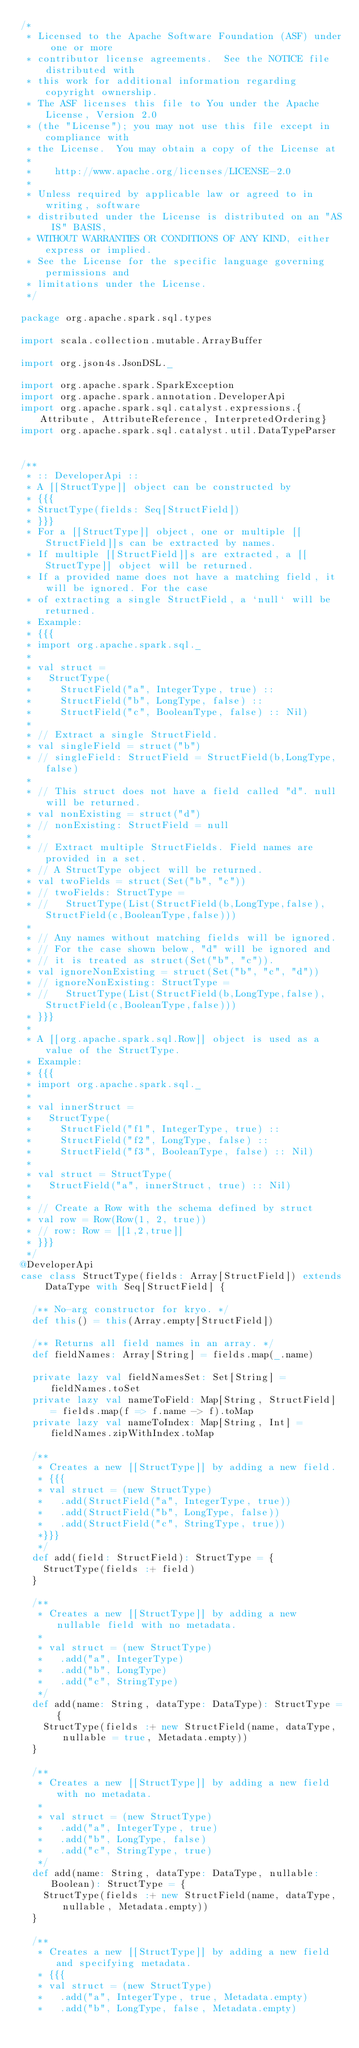<code> <loc_0><loc_0><loc_500><loc_500><_Scala_>/*
 * Licensed to the Apache Software Foundation (ASF) under one or more
 * contributor license agreements.  See the NOTICE file distributed with
 * this work for additional information regarding copyright ownership.
 * The ASF licenses this file to You under the Apache License, Version 2.0
 * (the "License"); you may not use this file except in compliance with
 * the License.  You may obtain a copy of the License at
 *
 *    http://www.apache.org/licenses/LICENSE-2.0
 *
 * Unless required by applicable law or agreed to in writing, software
 * distributed under the License is distributed on an "AS IS" BASIS,
 * WITHOUT WARRANTIES OR CONDITIONS OF ANY KIND, either express or implied.
 * See the License for the specific language governing permissions and
 * limitations under the License.
 */

package org.apache.spark.sql.types

import scala.collection.mutable.ArrayBuffer

import org.json4s.JsonDSL._

import org.apache.spark.SparkException
import org.apache.spark.annotation.DeveloperApi
import org.apache.spark.sql.catalyst.expressions.{Attribute, AttributeReference, InterpretedOrdering}
import org.apache.spark.sql.catalyst.util.DataTypeParser


/**
 * :: DeveloperApi ::
 * A [[StructType]] object can be constructed by
 * {{{
 * StructType(fields: Seq[StructField])
 * }}}
 * For a [[StructType]] object, one or multiple [[StructField]]s can be extracted by names.
 * If multiple [[StructField]]s are extracted, a [[StructType]] object will be returned.
 * If a provided name does not have a matching field, it will be ignored. For the case
 * of extracting a single StructField, a `null` will be returned.
 * Example:
 * {{{
 * import org.apache.spark.sql._
 *
 * val struct =
 *   StructType(
 *     StructField("a", IntegerType, true) ::
 *     StructField("b", LongType, false) ::
 *     StructField("c", BooleanType, false) :: Nil)
 *
 * // Extract a single StructField.
 * val singleField = struct("b")
 * // singleField: StructField = StructField(b,LongType,false)
 *
 * // This struct does not have a field called "d". null will be returned.
 * val nonExisting = struct("d")
 * // nonExisting: StructField = null
 *
 * // Extract multiple StructFields. Field names are provided in a set.
 * // A StructType object will be returned.
 * val twoFields = struct(Set("b", "c"))
 * // twoFields: StructType =
 * //   StructType(List(StructField(b,LongType,false), StructField(c,BooleanType,false)))
 *
 * // Any names without matching fields will be ignored.
 * // For the case shown below, "d" will be ignored and
 * // it is treated as struct(Set("b", "c")).
 * val ignoreNonExisting = struct(Set("b", "c", "d"))
 * // ignoreNonExisting: StructType =
 * //   StructType(List(StructField(b,LongType,false), StructField(c,BooleanType,false)))
 * }}}
 *
 * A [[org.apache.spark.sql.Row]] object is used as a value of the StructType.
 * Example:
 * {{{
 * import org.apache.spark.sql._
 *
 * val innerStruct =
 *   StructType(
 *     StructField("f1", IntegerType, true) ::
 *     StructField("f2", LongType, false) ::
 *     StructField("f3", BooleanType, false) :: Nil)
 *
 * val struct = StructType(
 *   StructField("a", innerStruct, true) :: Nil)
 *
 * // Create a Row with the schema defined by struct
 * val row = Row(Row(1, 2, true))
 * // row: Row = [[1,2,true]]
 * }}}
 */
@DeveloperApi
case class StructType(fields: Array[StructField]) extends DataType with Seq[StructField] {

  /** No-arg constructor for kryo. */
  def this() = this(Array.empty[StructField])

  /** Returns all field names in an array. */
  def fieldNames: Array[String] = fields.map(_.name)

  private lazy val fieldNamesSet: Set[String] = fieldNames.toSet
  private lazy val nameToField: Map[String, StructField] = fields.map(f => f.name -> f).toMap
  private lazy val nameToIndex: Map[String, Int] = fieldNames.zipWithIndex.toMap

  /**
   * Creates a new [[StructType]] by adding a new field.
   * {{{
   * val struct = (new StructType)
   *   .add(StructField("a", IntegerType, true))
   *   .add(StructField("b", LongType, false))
   *   .add(StructField("c", StringType, true))
   *}}}
   */
  def add(field: StructField): StructType = {
    StructType(fields :+ field)
  }

  /**
   * Creates a new [[StructType]] by adding a new nullable field with no metadata.
   *
   * val struct = (new StructType)
   *   .add("a", IntegerType)
   *   .add("b", LongType)
   *   .add("c", StringType)
   */
  def add(name: String, dataType: DataType): StructType = {
    StructType(fields :+ new StructField(name, dataType, nullable = true, Metadata.empty))
  }

  /**
   * Creates a new [[StructType]] by adding a new field with no metadata.
   *
   * val struct = (new StructType)
   *   .add("a", IntegerType, true)
   *   .add("b", LongType, false)
   *   .add("c", StringType, true)
   */
  def add(name: String, dataType: DataType, nullable: Boolean): StructType = {
    StructType(fields :+ new StructField(name, dataType, nullable, Metadata.empty))
  }

  /**
   * Creates a new [[StructType]] by adding a new field and specifying metadata.
   * {{{
   * val struct = (new StructType)
   *   .add("a", IntegerType, true, Metadata.empty)
   *   .add("b", LongType, false, Metadata.empty)</code> 